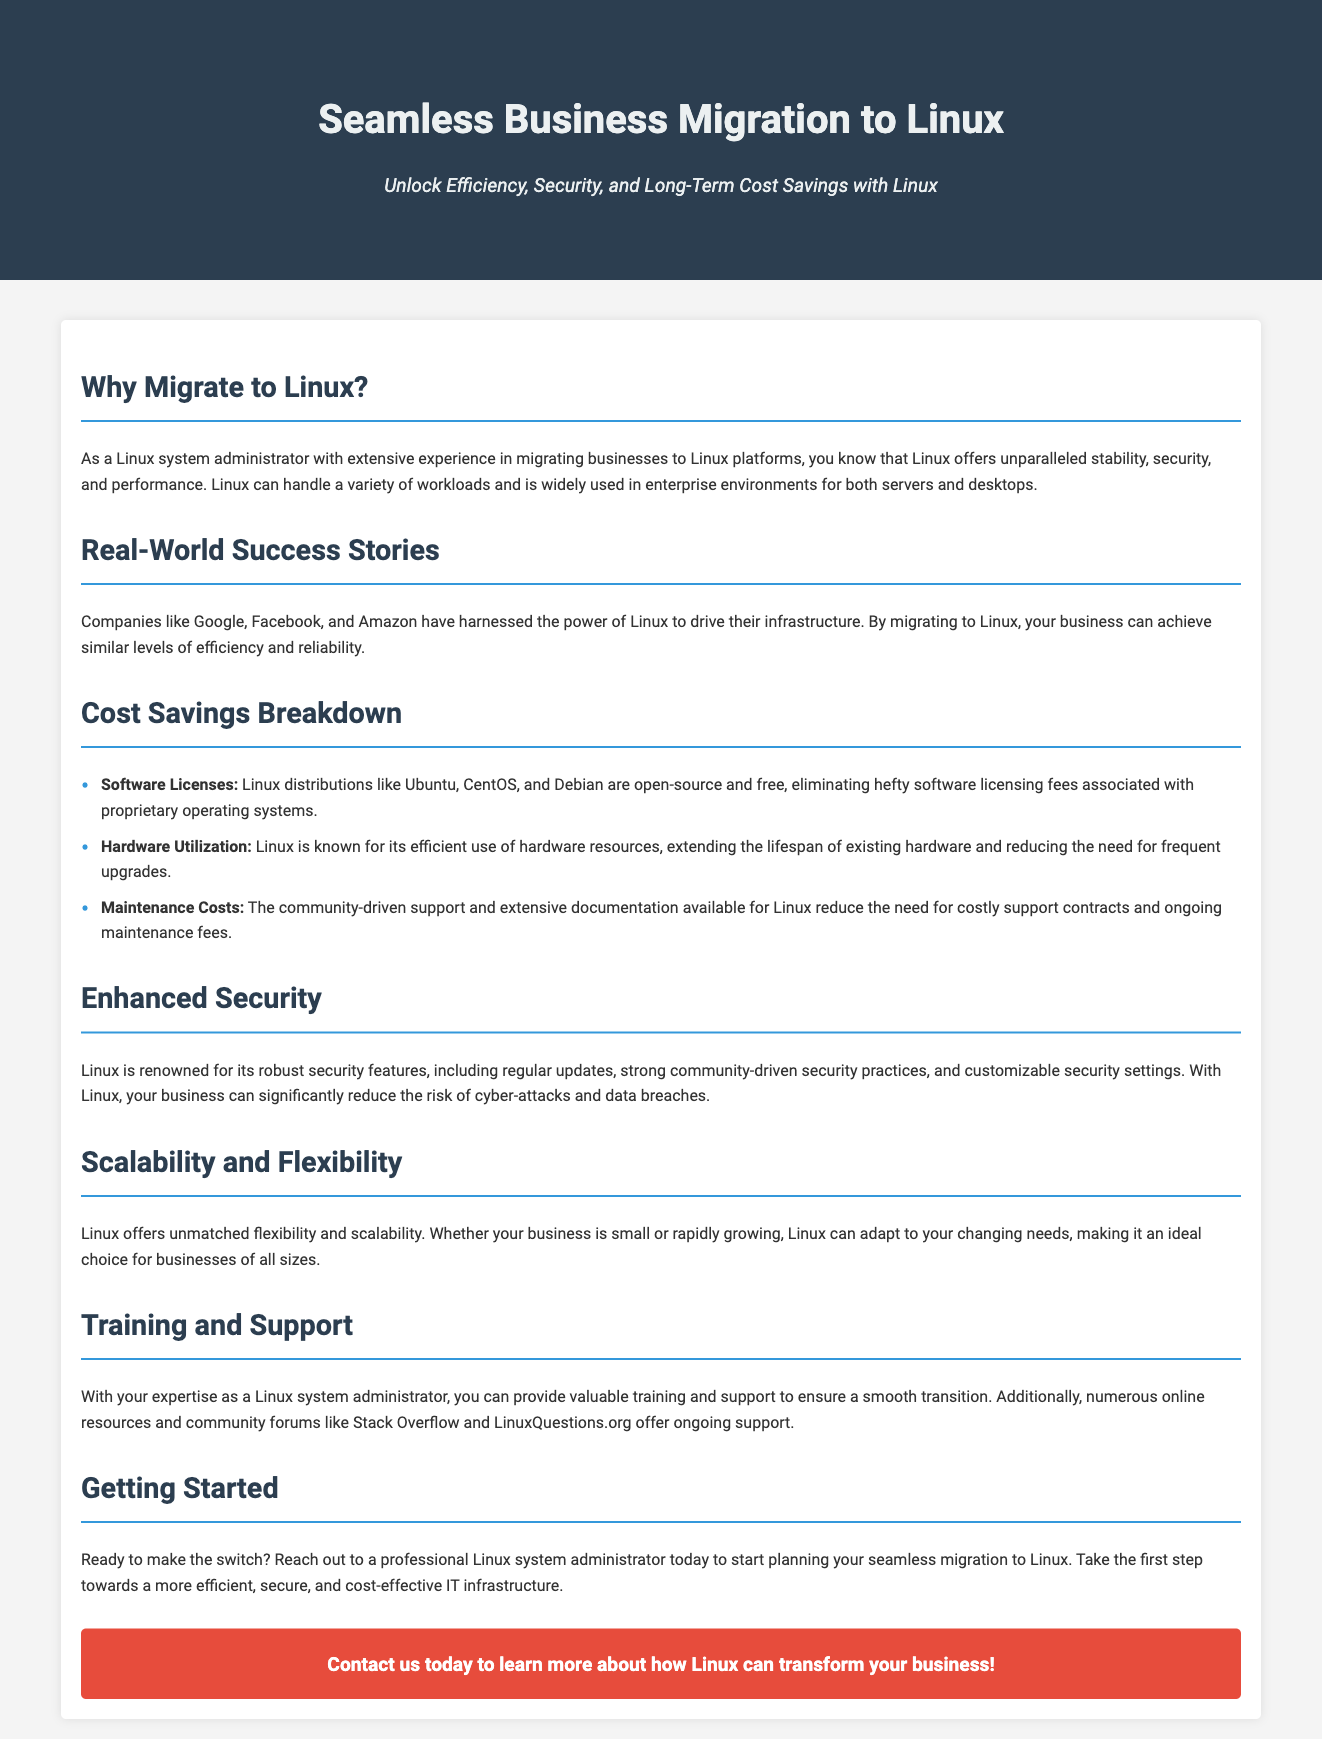What is the primary benefit of migrating to Linux? The document highlights that Linux offers unparalleled stability, security, and performance as the main benefit for business migration.
Answer: Stability, security, and performance Which companies are mentioned as successful examples of using Linux? The advertisement provides examples such as Google, Facebook, and Amazon to illustrate successful Linux implementations.
Answer: Google, Facebook, Amazon What type of operating systems do Linux distributions like Ubuntu and CentOS eliminate? The document states that these distributions eliminate hefty software licensing fees associated with proprietary operating systems.
Answer: Software licensing fees How does Linux affect hardware utilization according to the advertisement? The document mentions that Linux extends the lifespan of existing hardware and reduces the need for frequent upgrades due to efficient resource use.
Answer: Efficient use of hardware resources What is one of the identified security features of Linux? The document describes that Linux has regular updates which contribute to its robust security strategy.
Answer: Regular updates What aspect of Linux makes it adaptable for businesses of all sizes? The advertisement points out that unmatched flexibility and scalability in Linux facilitate adaptation to changing business needs.
Answer: Flexibility and scalability Who can provide training and support during the migration to Linux? The document indicates that a Linux system administrator can offer valuable training and support for a smooth transition.
Answer: Linux system administrator What is the call to action at the end of the advertisement? The document urges readers to reach out to a professional Linux system administrator to start planning their migration.
Answer: Contact us today to learn more 